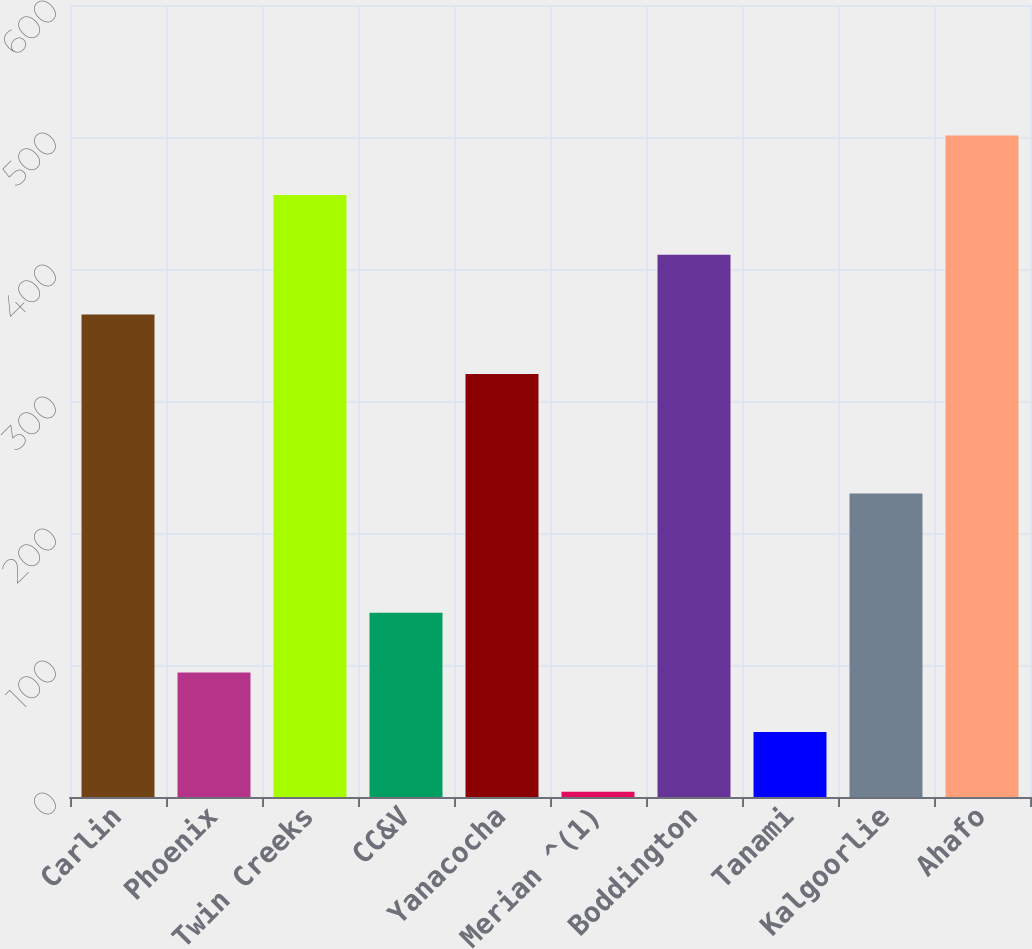<chart> <loc_0><loc_0><loc_500><loc_500><bar_chart><fcel>Carlin<fcel>Phoenix<fcel>Twin Creeks<fcel>CC&V<fcel>Yanacocha<fcel>Merian ^(1)<fcel>Boddington<fcel>Tanami<fcel>Kalgoorlie<fcel>Ahafo<nl><fcel>365.6<fcel>94.4<fcel>456<fcel>139.6<fcel>320.4<fcel>4<fcel>410.8<fcel>49.2<fcel>230<fcel>501.2<nl></chart> 